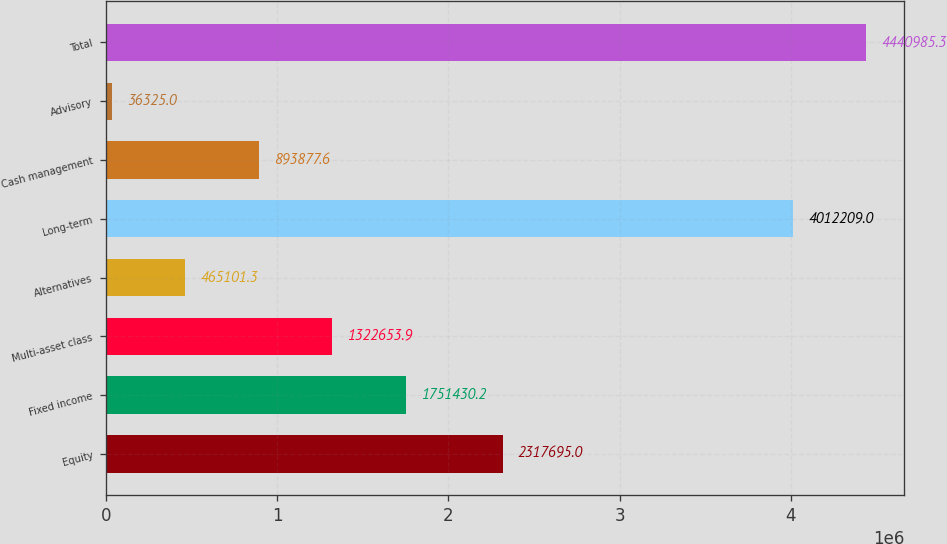Convert chart. <chart><loc_0><loc_0><loc_500><loc_500><bar_chart><fcel>Equity<fcel>Fixed income<fcel>Multi-asset class<fcel>Alternatives<fcel>Long-term<fcel>Cash management<fcel>Advisory<fcel>Total<nl><fcel>2.3177e+06<fcel>1.75143e+06<fcel>1.32265e+06<fcel>465101<fcel>4.01221e+06<fcel>893878<fcel>36325<fcel>4.44099e+06<nl></chart> 